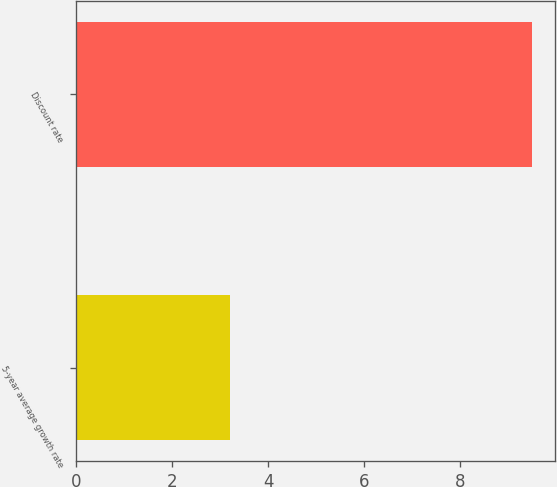<chart> <loc_0><loc_0><loc_500><loc_500><bar_chart><fcel>5-year average growth rate<fcel>Discount rate<nl><fcel>3.2<fcel>9.5<nl></chart> 